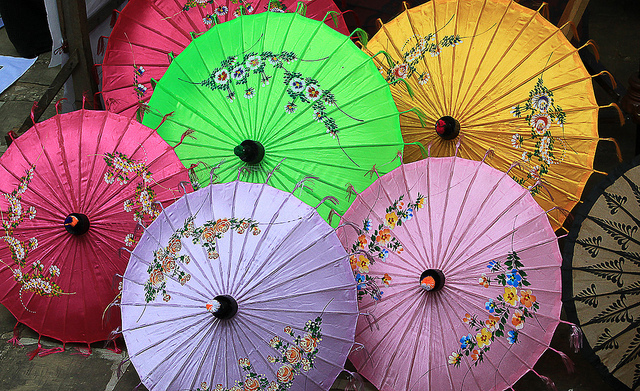<image>What continent are these fans from? I am not sure what continent these fans are from, but it could be Asia. What continent are these fans from? I don't know which continent these fans are from. It can be Asia or China. 